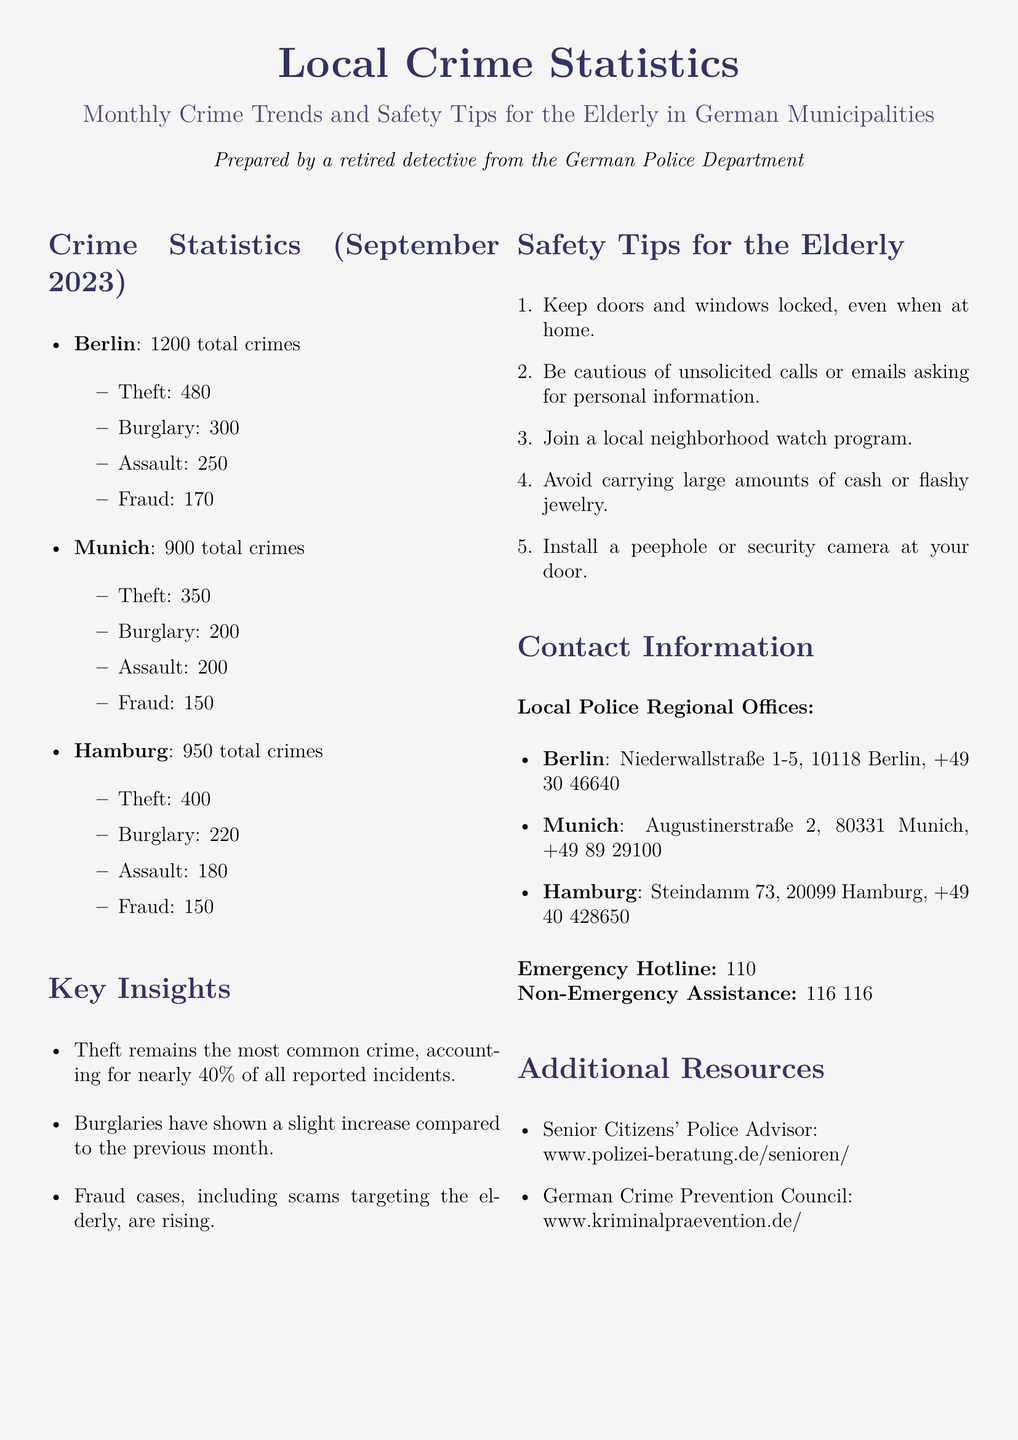What is the total number of crimes reported in Berlin? The total number of crimes reported in Berlin is mentioned in the statistics section of the document.
Answer: 1200 How many burglaries were reported in Munich? The number of burglaries in Munich can be found in the crime statistics section.
Answer: 200 Which crime has shown a slight increase compared to the previous month? The key insights section indicates which crime category has had a change in trends.
Answer: Burglaries What is one of the safety tips for the elderly? The safety tips section includes a list of recommendations for the elderly.
Answer: Keep doors and windows locked What is the contact number for the police in Hamburg? The contact information section provides details for contacting local police offices.
Answer: +49 40 428650 How many total crimes were reported in Hamburg? The total number of crimes for Hamburg is listed in the document.
Answer: 950 What percentage of all reported incidents does theft account for? The key insights section provides the percentage of theft among all crimes.
Answer: 40% Where can individuals find the Senior Citizens' Police Advisor? The additional resources section lists where to find information for seniors.
Answer: www.polizei-beratung.de/senioren/ Which city reported the highest number of fraud cases? The crime statistics section shows the breakdown of crimes by city.
Answer: Berlin 